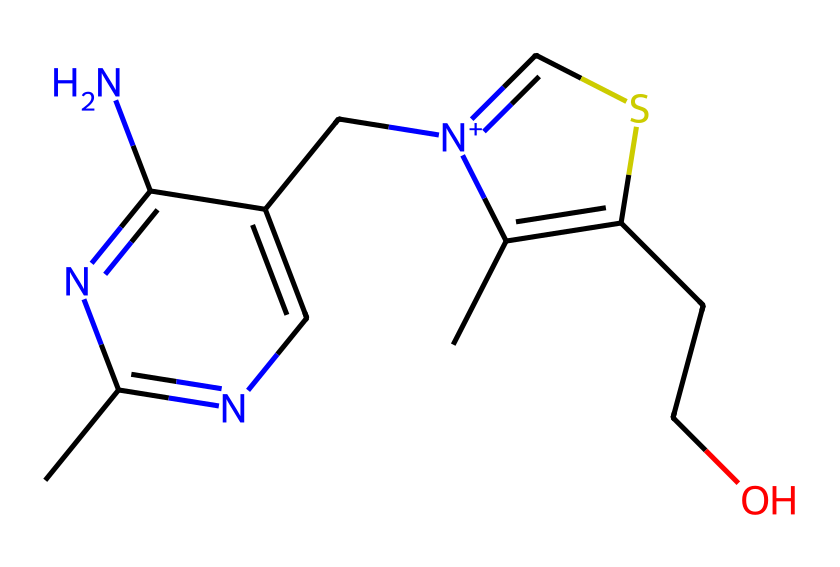what is the molecular formula of thiamine? To determine the molecular formula, identify the number of each type of atom in the structure from the SMILES. The structure contains carbon, hydrogen, nitrogen, and sulfur atoms. Count each type: 12 carbons, 17 hydrogens, 4 nitrogens, and 1 sulfur. Thus, the molecular formula is C12H17N4OS.
Answer: C12H17N4OS how many nitrogen atoms are present in thiamine? By analyzing the SMILES representation, count how many nitrogen atoms are indicated. The structure includes four nitrogen atoms.
Answer: 4 what type of bond connects the sulfur atom in thiamine? Examine the structure to identify the bond present with sulfur. In thiamine, the sulfur is connected by a single bond to a carbon atom as it is part of a thiazole ring.
Answer: single bond what functional groups are present in thiamine? Evaluate the structure to identify distinct functional groups. In thiamine, we can identify an amine group (-NH2) and a thiazole ring (which contains the sulfur) as prominent functional groups.
Answer: amine, thiazole what is thiamine classified as in terms of its chemical structure? Thiamine contains features typical of organosulfur compounds due to the presence of a sulfur atom within a ring structure and nitrogen atoms as well. It is classified broadly as a vitamin, specifically a B vitamin, but more specifically it's classified as a heterocyclic organosulfur compound due to the thiazole component.
Answer: heterocyclic organosulfur compound 